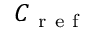<formula> <loc_0><loc_0><loc_500><loc_500>C _ { r e f }</formula> 